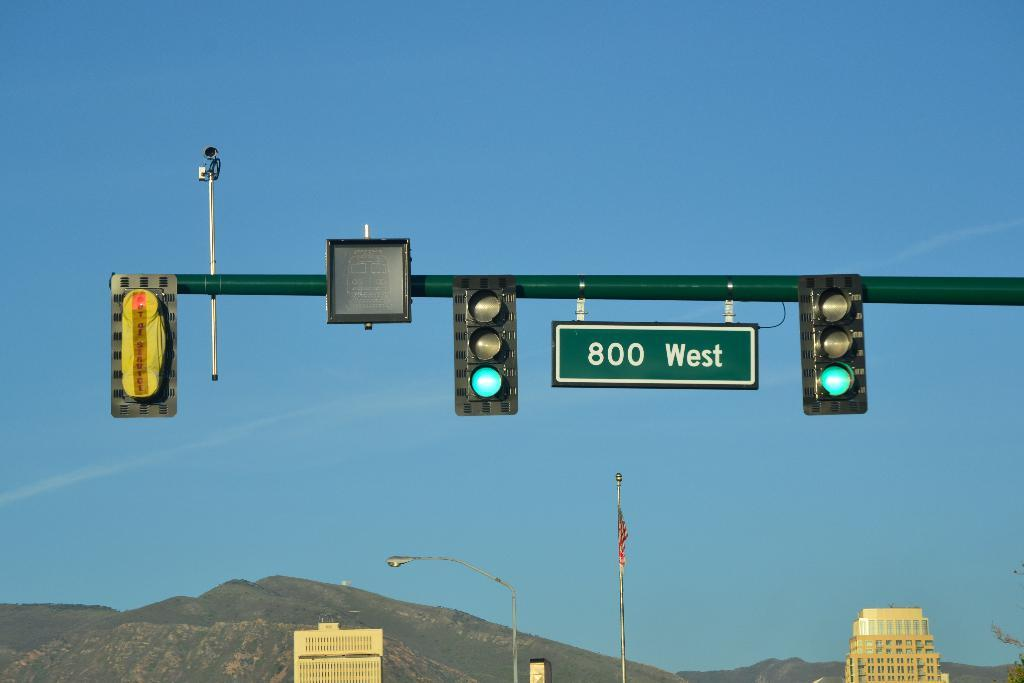<image>
Present a compact description of the photo's key features. Traffic lights display a green light with a sign showing they're on 800 West street. 